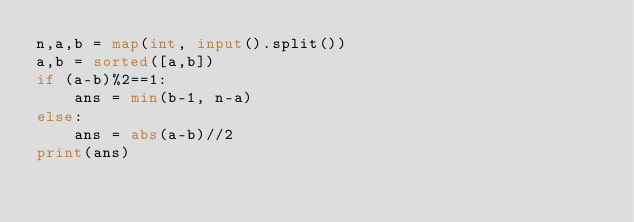Convert code to text. <code><loc_0><loc_0><loc_500><loc_500><_Python_>n,a,b = map(int, input().split())
a,b = sorted([a,b])
if (a-b)%2==1:
    ans = min(b-1, n-a)
else:
    ans = abs(a-b)//2
print(ans)</code> 